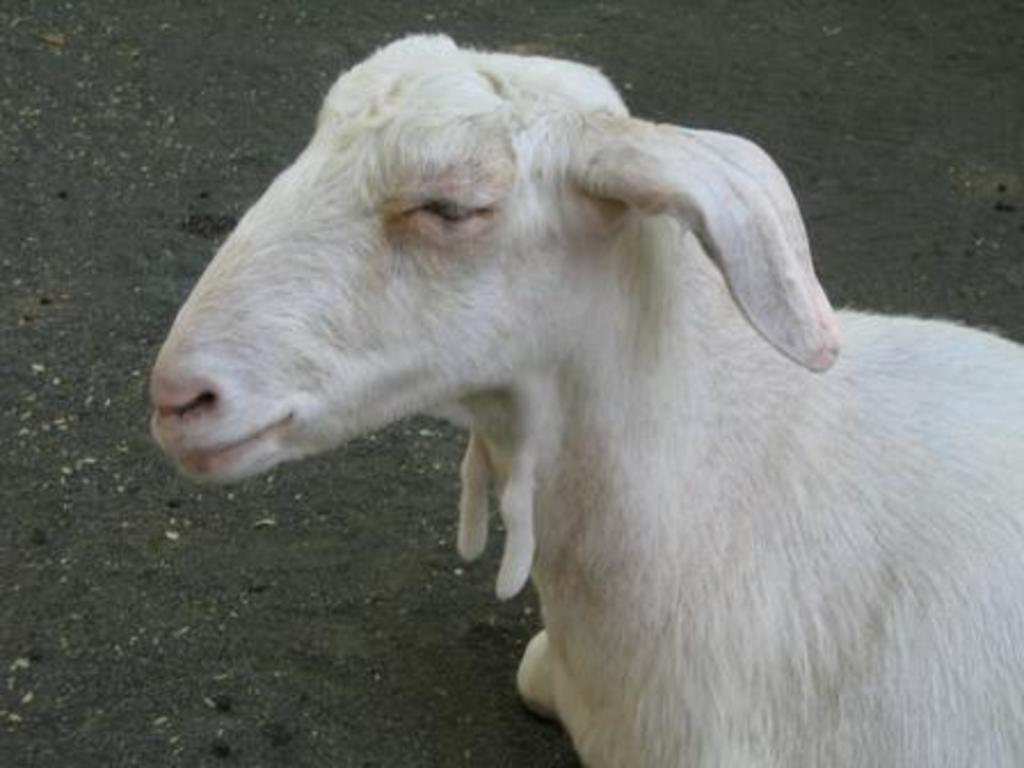What animal is present in the image? There is a goat in the image. Where is the goat located? The goat is on the ground. What type of feeling is the goat experiencing in the image? There is no indication of the goat's emotions or feelings in the image, so it cannot be determined. 